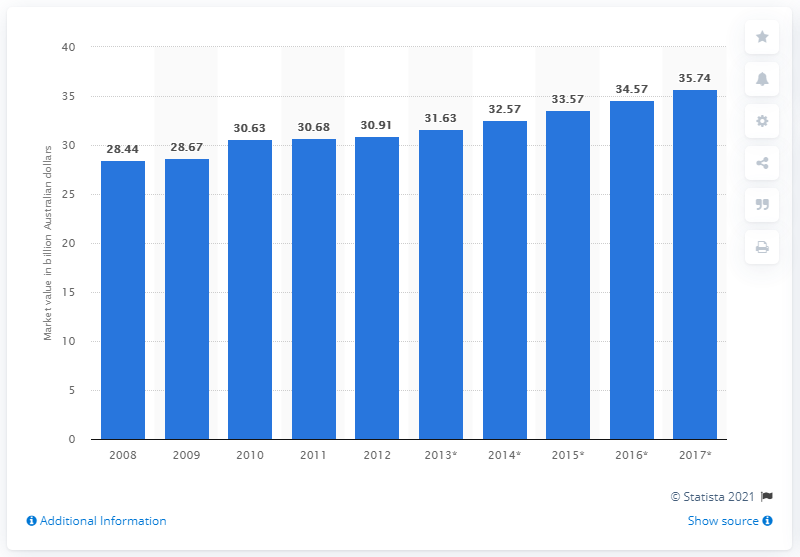Specify some key components in this picture. In 2017, the estimated value of the Australian entertainment and media market was 35.74. 